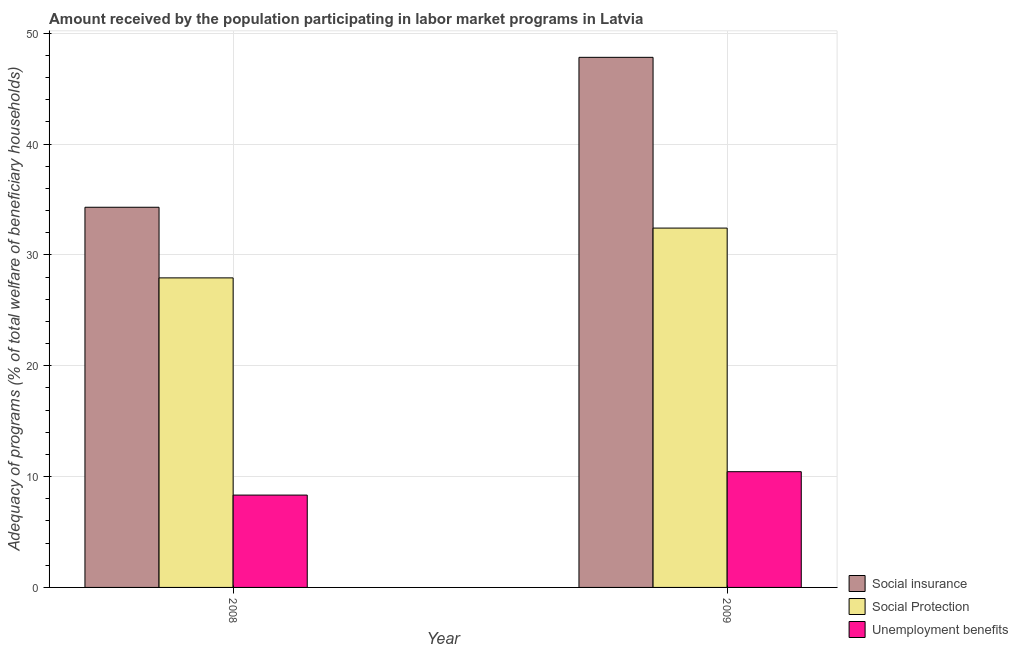Are the number of bars on each tick of the X-axis equal?
Provide a short and direct response. Yes. How many bars are there on the 1st tick from the left?
Your response must be concise. 3. How many bars are there on the 2nd tick from the right?
Offer a terse response. 3. What is the amount received by the population participating in social protection programs in 2008?
Provide a short and direct response. 27.93. Across all years, what is the maximum amount received by the population participating in social protection programs?
Offer a very short reply. 32.42. Across all years, what is the minimum amount received by the population participating in social insurance programs?
Offer a terse response. 34.3. In which year was the amount received by the population participating in social protection programs minimum?
Ensure brevity in your answer.  2008. What is the total amount received by the population participating in unemployment benefits programs in the graph?
Your response must be concise. 18.77. What is the difference between the amount received by the population participating in unemployment benefits programs in 2008 and that in 2009?
Your answer should be compact. -2.11. What is the difference between the amount received by the population participating in social protection programs in 2008 and the amount received by the population participating in social insurance programs in 2009?
Give a very brief answer. -4.49. What is the average amount received by the population participating in social protection programs per year?
Make the answer very short. 30.17. In the year 2009, what is the difference between the amount received by the population participating in social insurance programs and amount received by the population participating in unemployment benefits programs?
Provide a short and direct response. 0. What is the ratio of the amount received by the population participating in unemployment benefits programs in 2008 to that in 2009?
Provide a short and direct response. 0.8. What does the 3rd bar from the left in 2009 represents?
Give a very brief answer. Unemployment benefits. What does the 2nd bar from the right in 2008 represents?
Your answer should be very brief. Social Protection. Is it the case that in every year, the sum of the amount received by the population participating in social insurance programs and amount received by the population participating in social protection programs is greater than the amount received by the population participating in unemployment benefits programs?
Your answer should be compact. Yes. Are all the bars in the graph horizontal?
Make the answer very short. No. How many years are there in the graph?
Your answer should be compact. 2. What is the difference between two consecutive major ticks on the Y-axis?
Ensure brevity in your answer.  10. Are the values on the major ticks of Y-axis written in scientific E-notation?
Offer a very short reply. No. How many legend labels are there?
Your response must be concise. 3. How are the legend labels stacked?
Your answer should be very brief. Vertical. What is the title of the graph?
Your answer should be very brief. Amount received by the population participating in labor market programs in Latvia. What is the label or title of the X-axis?
Give a very brief answer. Year. What is the label or title of the Y-axis?
Your answer should be compact. Adequacy of programs (% of total welfare of beneficiary households). What is the Adequacy of programs (% of total welfare of beneficiary households) of Social insurance in 2008?
Provide a succinct answer. 34.3. What is the Adequacy of programs (% of total welfare of beneficiary households) of Social Protection in 2008?
Your answer should be compact. 27.93. What is the Adequacy of programs (% of total welfare of beneficiary households) in Unemployment benefits in 2008?
Your answer should be compact. 8.33. What is the Adequacy of programs (% of total welfare of beneficiary households) in Social insurance in 2009?
Provide a succinct answer. 47.82. What is the Adequacy of programs (% of total welfare of beneficiary households) in Social Protection in 2009?
Make the answer very short. 32.42. What is the Adequacy of programs (% of total welfare of beneficiary households) in Unemployment benefits in 2009?
Your answer should be very brief. 10.44. Across all years, what is the maximum Adequacy of programs (% of total welfare of beneficiary households) of Social insurance?
Your answer should be compact. 47.82. Across all years, what is the maximum Adequacy of programs (% of total welfare of beneficiary households) in Social Protection?
Ensure brevity in your answer.  32.42. Across all years, what is the maximum Adequacy of programs (% of total welfare of beneficiary households) in Unemployment benefits?
Make the answer very short. 10.44. Across all years, what is the minimum Adequacy of programs (% of total welfare of beneficiary households) of Social insurance?
Provide a succinct answer. 34.3. Across all years, what is the minimum Adequacy of programs (% of total welfare of beneficiary households) in Social Protection?
Offer a very short reply. 27.93. Across all years, what is the minimum Adequacy of programs (% of total welfare of beneficiary households) in Unemployment benefits?
Your response must be concise. 8.33. What is the total Adequacy of programs (% of total welfare of beneficiary households) of Social insurance in the graph?
Offer a terse response. 82.12. What is the total Adequacy of programs (% of total welfare of beneficiary households) in Social Protection in the graph?
Offer a very short reply. 60.34. What is the total Adequacy of programs (% of total welfare of beneficiary households) of Unemployment benefits in the graph?
Your answer should be very brief. 18.77. What is the difference between the Adequacy of programs (% of total welfare of beneficiary households) in Social insurance in 2008 and that in 2009?
Make the answer very short. -13.53. What is the difference between the Adequacy of programs (% of total welfare of beneficiary households) in Social Protection in 2008 and that in 2009?
Offer a very short reply. -4.49. What is the difference between the Adequacy of programs (% of total welfare of beneficiary households) of Unemployment benefits in 2008 and that in 2009?
Your answer should be very brief. -2.11. What is the difference between the Adequacy of programs (% of total welfare of beneficiary households) in Social insurance in 2008 and the Adequacy of programs (% of total welfare of beneficiary households) in Social Protection in 2009?
Ensure brevity in your answer.  1.88. What is the difference between the Adequacy of programs (% of total welfare of beneficiary households) of Social insurance in 2008 and the Adequacy of programs (% of total welfare of beneficiary households) of Unemployment benefits in 2009?
Ensure brevity in your answer.  23.86. What is the difference between the Adequacy of programs (% of total welfare of beneficiary households) in Social Protection in 2008 and the Adequacy of programs (% of total welfare of beneficiary households) in Unemployment benefits in 2009?
Your answer should be compact. 17.48. What is the average Adequacy of programs (% of total welfare of beneficiary households) in Social insurance per year?
Offer a very short reply. 41.06. What is the average Adequacy of programs (% of total welfare of beneficiary households) of Social Protection per year?
Your answer should be very brief. 30.17. What is the average Adequacy of programs (% of total welfare of beneficiary households) of Unemployment benefits per year?
Keep it short and to the point. 9.39. In the year 2008, what is the difference between the Adequacy of programs (% of total welfare of beneficiary households) of Social insurance and Adequacy of programs (% of total welfare of beneficiary households) of Social Protection?
Your response must be concise. 6.37. In the year 2008, what is the difference between the Adequacy of programs (% of total welfare of beneficiary households) in Social insurance and Adequacy of programs (% of total welfare of beneficiary households) in Unemployment benefits?
Keep it short and to the point. 25.97. In the year 2008, what is the difference between the Adequacy of programs (% of total welfare of beneficiary households) of Social Protection and Adequacy of programs (% of total welfare of beneficiary households) of Unemployment benefits?
Your answer should be compact. 19.59. In the year 2009, what is the difference between the Adequacy of programs (% of total welfare of beneficiary households) in Social insurance and Adequacy of programs (% of total welfare of beneficiary households) in Social Protection?
Your answer should be compact. 15.41. In the year 2009, what is the difference between the Adequacy of programs (% of total welfare of beneficiary households) in Social insurance and Adequacy of programs (% of total welfare of beneficiary households) in Unemployment benefits?
Your answer should be very brief. 37.38. In the year 2009, what is the difference between the Adequacy of programs (% of total welfare of beneficiary households) in Social Protection and Adequacy of programs (% of total welfare of beneficiary households) in Unemployment benefits?
Offer a very short reply. 21.98. What is the ratio of the Adequacy of programs (% of total welfare of beneficiary households) of Social insurance in 2008 to that in 2009?
Your answer should be very brief. 0.72. What is the ratio of the Adequacy of programs (% of total welfare of beneficiary households) in Social Protection in 2008 to that in 2009?
Your answer should be very brief. 0.86. What is the ratio of the Adequacy of programs (% of total welfare of beneficiary households) in Unemployment benefits in 2008 to that in 2009?
Give a very brief answer. 0.8. What is the difference between the highest and the second highest Adequacy of programs (% of total welfare of beneficiary households) of Social insurance?
Ensure brevity in your answer.  13.53. What is the difference between the highest and the second highest Adequacy of programs (% of total welfare of beneficiary households) in Social Protection?
Provide a succinct answer. 4.49. What is the difference between the highest and the second highest Adequacy of programs (% of total welfare of beneficiary households) of Unemployment benefits?
Make the answer very short. 2.11. What is the difference between the highest and the lowest Adequacy of programs (% of total welfare of beneficiary households) in Social insurance?
Provide a short and direct response. 13.53. What is the difference between the highest and the lowest Adequacy of programs (% of total welfare of beneficiary households) of Social Protection?
Give a very brief answer. 4.49. What is the difference between the highest and the lowest Adequacy of programs (% of total welfare of beneficiary households) in Unemployment benefits?
Your answer should be very brief. 2.11. 